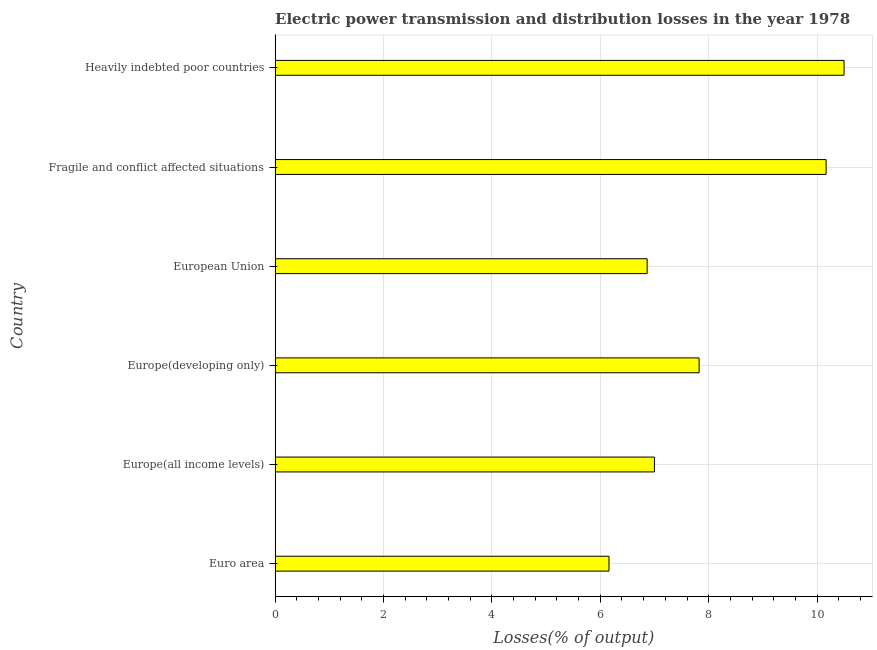Does the graph contain any zero values?
Offer a very short reply. No. Does the graph contain grids?
Provide a succinct answer. Yes. What is the title of the graph?
Your answer should be compact. Electric power transmission and distribution losses in the year 1978. What is the label or title of the X-axis?
Your answer should be compact. Losses(% of output). What is the label or title of the Y-axis?
Your answer should be compact. Country. What is the electric power transmission and distribution losses in Europe(developing only)?
Your answer should be very brief. 7.82. Across all countries, what is the maximum electric power transmission and distribution losses?
Offer a very short reply. 10.5. Across all countries, what is the minimum electric power transmission and distribution losses?
Keep it short and to the point. 6.16. In which country was the electric power transmission and distribution losses maximum?
Provide a short and direct response. Heavily indebted poor countries. In which country was the electric power transmission and distribution losses minimum?
Make the answer very short. Euro area. What is the sum of the electric power transmission and distribution losses?
Offer a terse response. 48.51. What is the difference between the electric power transmission and distribution losses in Europe(all income levels) and Europe(developing only)?
Keep it short and to the point. -0.82. What is the average electric power transmission and distribution losses per country?
Ensure brevity in your answer.  8.09. What is the median electric power transmission and distribution losses?
Your response must be concise. 7.41. In how many countries, is the electric power transmission and distribution losses greater than 7.2 %?
Your response must be concise. 3. What is the ratio of the electric power transmission and distribution losses in Europe(all income levels) to that in Fragile and conflict affected situations?
Provide a succinct answer. 0.69. What is the difference between the highest and the second highest electric power transmission and distribution losses?
Give a very brief answer. 0.33. Is the sum of the electric power transmission and distribution losses in European Union and Fragile and conflict affected situations greater than the maximum electric power transmission and distribution losses across all countries?
Keep it short and to the point. Yes. What is the difference between the highest and the lowest electric power transmission and distribution losses?
Keep it short and to the point. 4.34. How many bars are there?
Keep it short and to the point. 6. Are all the bars in the graph horizontal?
Your response must be concise. Yes. Are the values on the major ticks of X-axis written in scientific E-notation?
Your answer should be very brief. No. What is the Losses(% of output) in Euro area?
Your answer should be compact. 6.16. What is the Losses(% of output) of Europe(all income levels)?
Make the answer very short. 7. What is the Losses(% of output) in Europe(developing only)?
Offer a very short reply. 7.82. What is the Losses(% of output) in European Union?
Ensure brevity in your answer.  6.86. What is the Losses(% of output) in Fragile and conflict affected situations?
Your response must be concise. 10.17. What is the Losses(% of output) of Heavily indebted poor countries?
Make the answer very short. 10.5. What is the difference between the Losses(% of output) in Euro area and Europe(all income levels)?
Provide a short and direct response. -0.84. What is the difference between the Losses(% of output) in Euro area and Europe(developing only)?
Ensure brevity in your answer.  -1.66. What is the difference between the Losses(% of output) in Euro area and European Union?
Provide a short and direct response. -0.7. What is the difference between the Losses(% of output) in Euro area and Fragile and conflict affected situations?
Your answer should be very brief. -4.01. What is the difference between the Losses(% of output) in Euro area and Heavily indebted poor countries?
Make the answer very short. -4.34. What is the difference between the Losses(% of output) in Europe(all income levels) and Europe(developing only)?
Offer a very short reply. -0.82. What is the difference between the Losses(% of output) in Europe(all income levels) and European Union?
Your answer should be very brief. 0.13. What is the difference between the Losses(% of output) in Europe(all income levels) and Fragile and conflict affected situations?
Offer a very short reply. -3.17. What is the difference between the Losses(% of output) in Europe(all income levels) and Heavily indebted poor countries?
Make the answer very short. -3.5. What is the difference between the Losses(% of output) in Europe(developing only) and European Union?
Your response must be concise. 0.96. What is the difference between the Losses(% of output) in Europe(developing only) and Fragile and conflict affected situations?
Your response must be concise. -2.34. What is the difference between the Losses(% of output) in Europe(developing only) and Heavily indebted poor countries?
Your answer should be very brief. -2.67. What is the difference between the Losses(% of output) in European Union and Fragile and conflict affected situations?
Offer a very short reply. -3.3. What is the difference between the Losses(% of output) in European Union and Heavily indebted poor countries?
Your answer should be compact. -3.63. What is the difference between the Losses(% of output) in Fragile and conflict affected situations and Heavily indebted poor countries?
Offer a terse response. -0.33. What is the ratio of the Losses(% of output) in Euro area to that in Europe(developing only)?
Give a very brief answer. 0.79. What is the ratio of the Losses(% of output) in Euro area to that in European Union?
Ensure brevity in your answer.  0.9. What is the ratio of the Losses(% of output) in Euro area to that in Fragile and conflict affected situations?
Provide a succinct answer. 0.61. What is the ratio of the Losses(% of output) in Euro area to that in Heavily indebted poor countries?
Keep it short and to the point. 0.59. What is the ratio of the Losses(% of output) in Europe(all income levels) to that in Europe(developing only)?
Ensure brevity in your answer.  0.9. What is the ratio of the Losses(% of output) in Europe(all income levels) to that in Fragile and conflict affected situations?
Keep it short and to the point. 0.69. What is the ratio of the Losses(% of output) in Europe(all income levels) to that in Heavily indebted poor countries?
Provide a short and direct response. 0.67. What is the ratio of the Losses(% of output) in Europe(developing only) to that in European Union?
Your answer should be very brief. 1.14. What is the ratio of the Losses(% of output) in Europe(developing only) to that in Fragile and conflict affected situations?
Offer a very short reply. 0.77. What is the ratio of the Losses(% of output) in Europe(developing only) to that in Heavily indebted poor countries?
Your answer should be very brief. 0.74. What is the ratio of the Losses(% of output) in European Union to that in Fragile and conflict affected situations?
Your answer should be compact. 0.68. What is the ratio of the Losses(% of output) in European Union to that in Heavily indebted poor countries?
Your answer should be very brief. 0.65. What is the ratio of the Losses(% of output) in Fragile and conflict affected situations to that in Heavily indebted poor countries?
Your response must be concise. 0.97. 